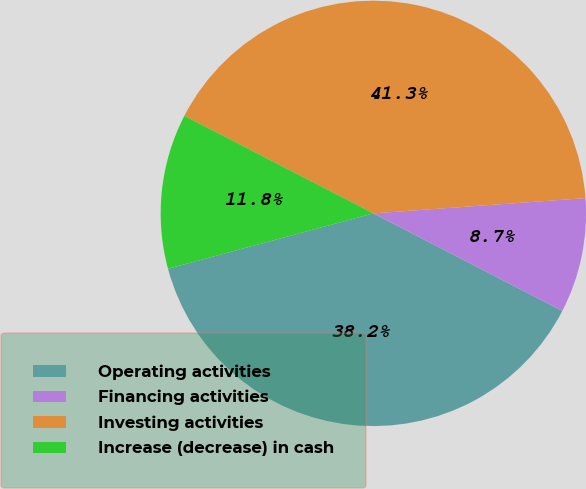Convert chart. <chart><loc_0><loc_0><loc_500><loc_500><pie_chart><fcel>Operating activities<fcel>Financing activities<fcel>Investing activities<fcel>Increase (decrease) in cash<nl><fcel>38.22%<fcel>8.73%<fcel>41.27%<fcel>11.78%<nl></chart> 